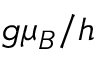Convert formula to latex. <formula><loc_0><loc_0><loc_500><loc_500>g \mu _ { B } / h</formula> 